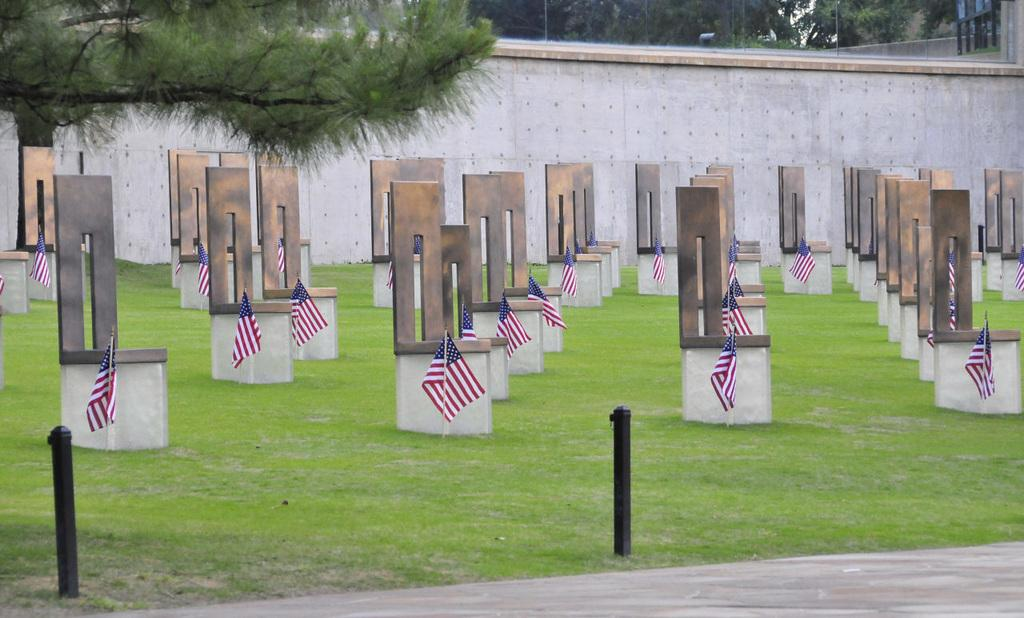What type of structures are present in the image? There are grave stones and flags in the image. What is the ground covered with in the image? There is grass on the ground in the image. What type of vegetation can be seen in the image? There are trees in the image. What is the background of the image made up of? There is a wall in the image. What type of circle is visible in the image? There is no circle present in the image. Who is the father in the image? There is no person, let alone a father, present in the image. 